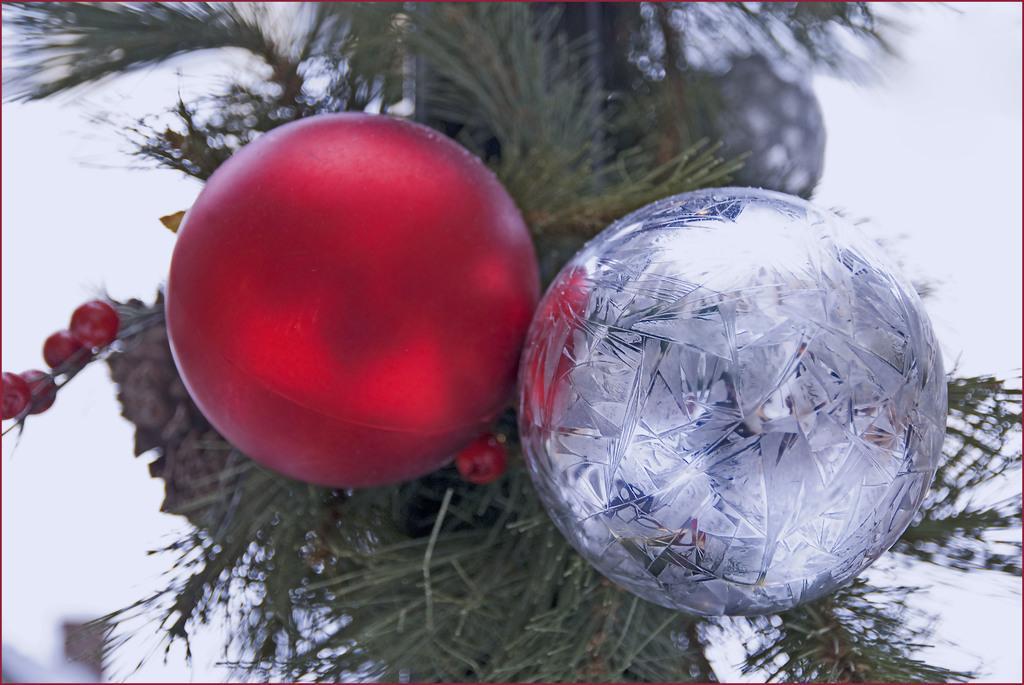In one or two sentences, can you explain what this image depicts? In the image we can see there are decorative balls which are in red colour and silver colour kept on the tree. Background of the image is blurred. 